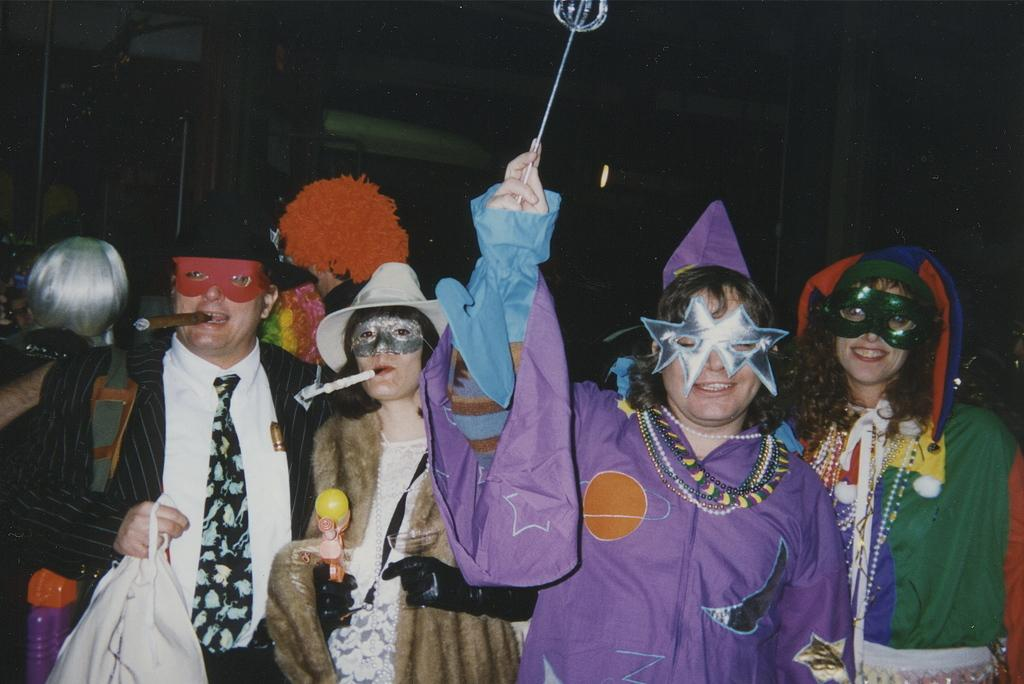How many people are in the group in the image? There is a group of persons in the image, but the exact number is not specified. What are the persons in the group doing? The persons in the group are standing. What are the persons wearing in the image? The persons are wearing carnival dress. Where is the group located in the image? The group is at the bottom of the image. What type of horn can be heard in the image? There is no horn present in the image, and therefore no sound can be heard. 